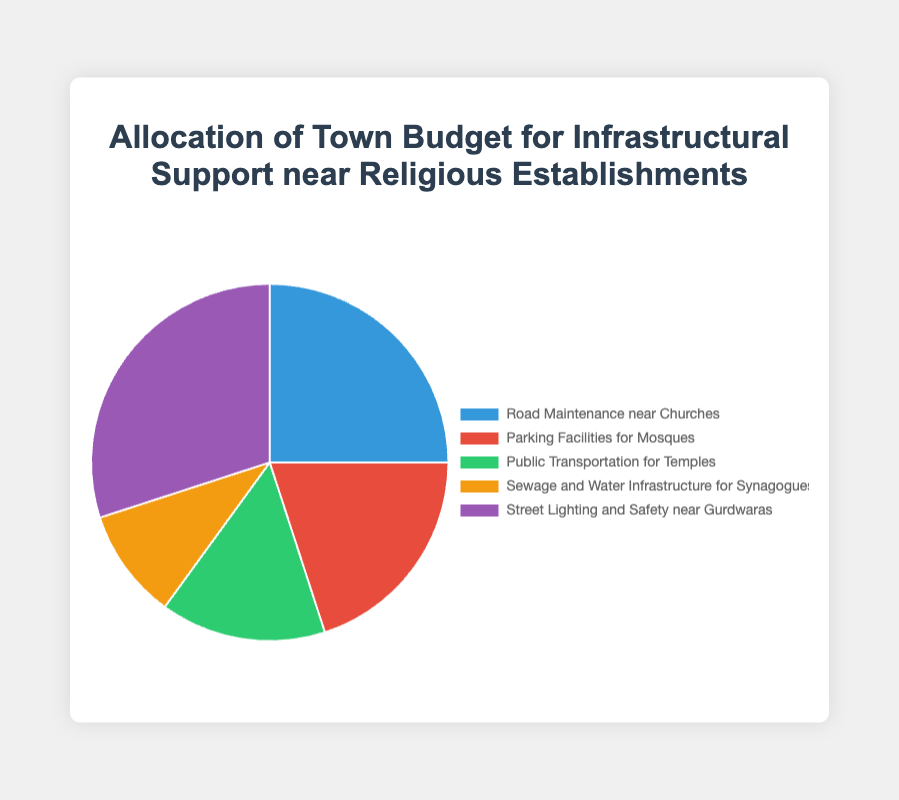What's the largest budget category? The largest category can be determined by looking at the segment with the highest percentage. Here, the "Street Lighting and Safety near Gurdwaras" has the highest percentage at 30%.
Answer: Street Lighting and Safety near Gurdwaras What's the combined budget percentage for Road Maintenance near Churches and Parking Facilities for Mosques? To find the combined budget for these two categories, simply add their percentages: Road Maintenance near Churches (25%) + Parking Facilities for Mosques (20%) = 45%.
Answer: 45% Which budget category has the smallest percentage? The category with the smallest percentage can be found by looking at the segment with the lowest value. Here, "Sewage and Water Infrastructure for Synagogues" has the smallest percentage at 10%.
Answer: Sewage and Water Infrastructure for Synagogues How much higher is the budget percentage for Street Lighting and Safety near Gurdwaras compared to Sewage and Water Infrastructure for Synagogues? Subtract the percentage of Sewage and Water Infrastructure for Synagogues (10%) from the percentage of Street Lighting and Safety near Gurdwaras (30%): 30% - 10% = 20%.
Answer: 20% Which two categories have the closest budget percentages? The two closest budget percentages are those of "Parking Facilities for Mosques" (20%) and "Public Transportation for Temples" (15%), with a difference of 5%.
Answer: Parking Facilities for Mosques and Public Transportation for Temples What is the average budget percentage allocated among all categories? Sum all the percentages and divide by the number of categories: (25% + 20% + 15% + 10% + 30%) / 5 = 100% / 5 = 20%.
Answer: 20% If the budget for Road Maintenance near Churches was increased by 5%, which category would then have the highest budget percentage? Increasing the budget for Road Maintenance near Churches by 5% makes it 25% + 5% = 30%. Since "Street Lighting and Safety near Gurdwaras" also has 30%, there will be a tie for the highest percentage between these two categories.
Answer: Street Lighting and Safety near Gurdwaras and Road Maintenance near Churches (tie) 